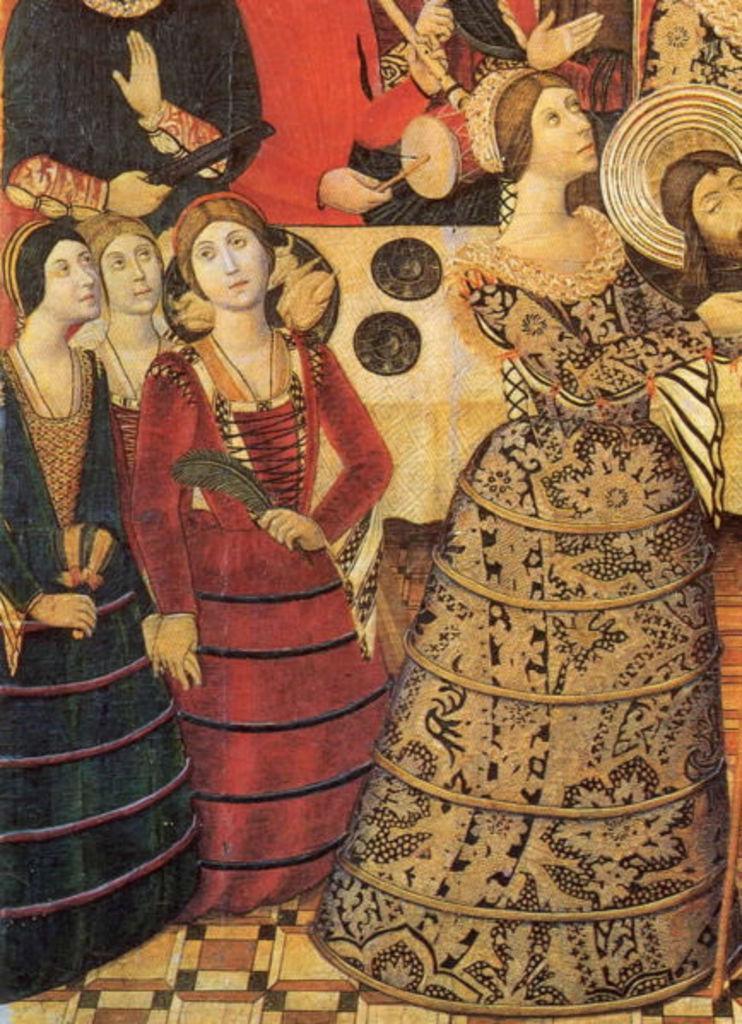How would you summarize this image in a sentence or two? In this image we can see a painting. In the painting we can see a group of persons. Among them a person is playing a musical instrument. 